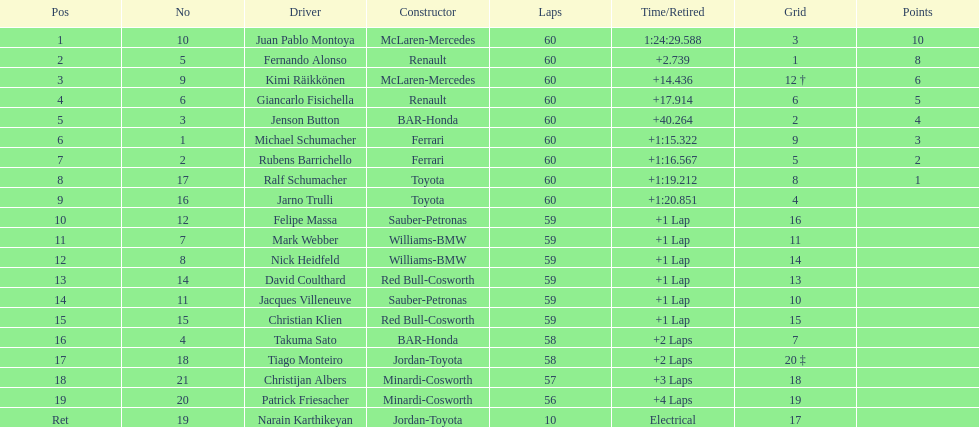Out of all drivers, who has earned the fewest points? Ralf Schumacher. 